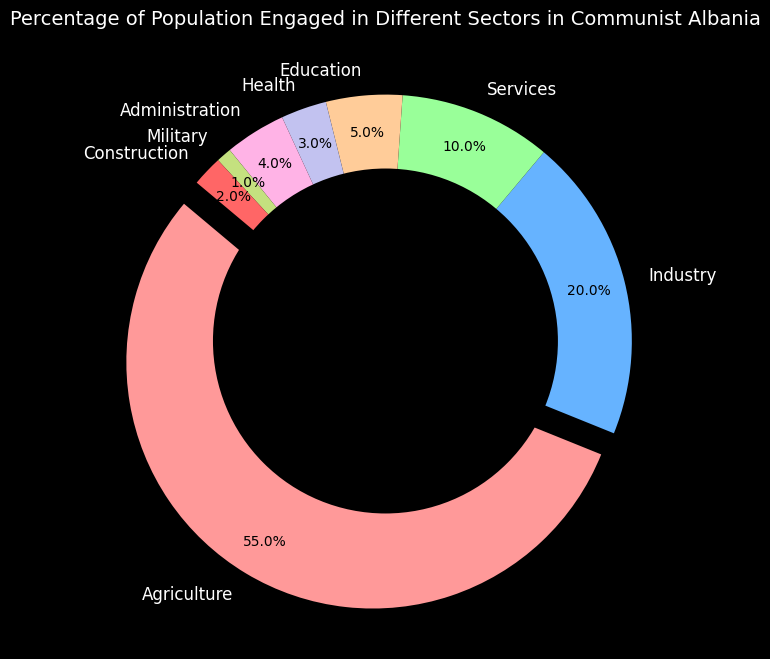Which sector has the most significant share of the population? The wedge representing the "Agriculture" sector is the largest with the percentage label showing 55%, indicating it has the most significant share of the population.
Answer: Agriculture What is the total percentage of the population engaged in Industry and Services combined? Combining the percentages for "Industry" (20%) and "Services" (10%) gives a total percentage of 20 + 10 = 30%.
Answer: 30% How does the population engaged in Education compare to that in Administration? The population percentage in "Education" is 5% and in "Administration" is 4%. Thus, the population in Education is slightly higher than in Administration.
Answer: Education is higher Which sector has the smallest share of the population? The segment labelled with 1% represents the "Military" sector, making it the smallest share of the population.
Answer: Military What percentage of the population is engaged in Health, Administration, and Military sectors combined? Adding up the percentages for "Health" (3%), "Administration" (4%), and "Military" (1%) gives a total percentage of 3 + 4 + 1 = 8%.
Answer: 8% Is the percentage of the population in Construction greater than that in Military? The percentage of the population engaged in "Construction" is 2%, whereas in "Military" it is 1%, so Construction has a greater percentage.
Answer: Yes What proportion of the population is engaged in sectors other than Agriculture? Adding up all sectors except "Agriculture": 20% (Industry) + 10% (Services) + 5% (Education) + 3% (Health) + 4% (Administration) + 1% (Military) + 2% (Construction) gives a total: 45%. Therefore, the remaining population is 100% - 55% = 45%.
Answer: 45% How does the share of the population in Services compare visually to the share in Health? The wedge for "Services" is wider than that for "Health" and is visually three times larger (Services at 10% and Health at 3%).
Answer: Services is larger 